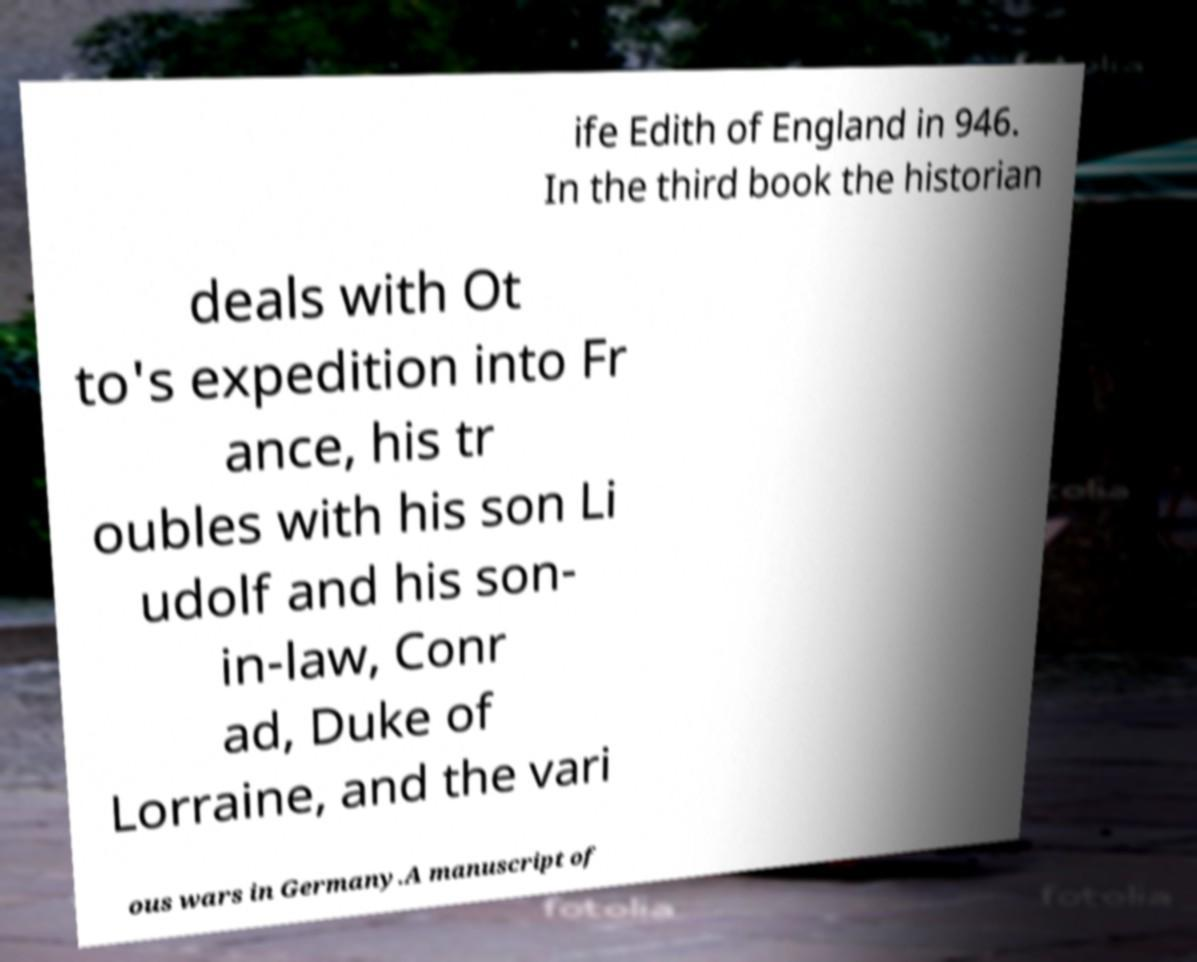Please read and relay the text visible in this image. What does it say? ife Edith of England in 946. In the third book the historian deals with Ot to's expedition into Fr ance, his tr oubles with his son Li udolf and his son- in-law, Conr ad, Duke of Lorraine, and the vari ous wars in Germany.A manuscript of 